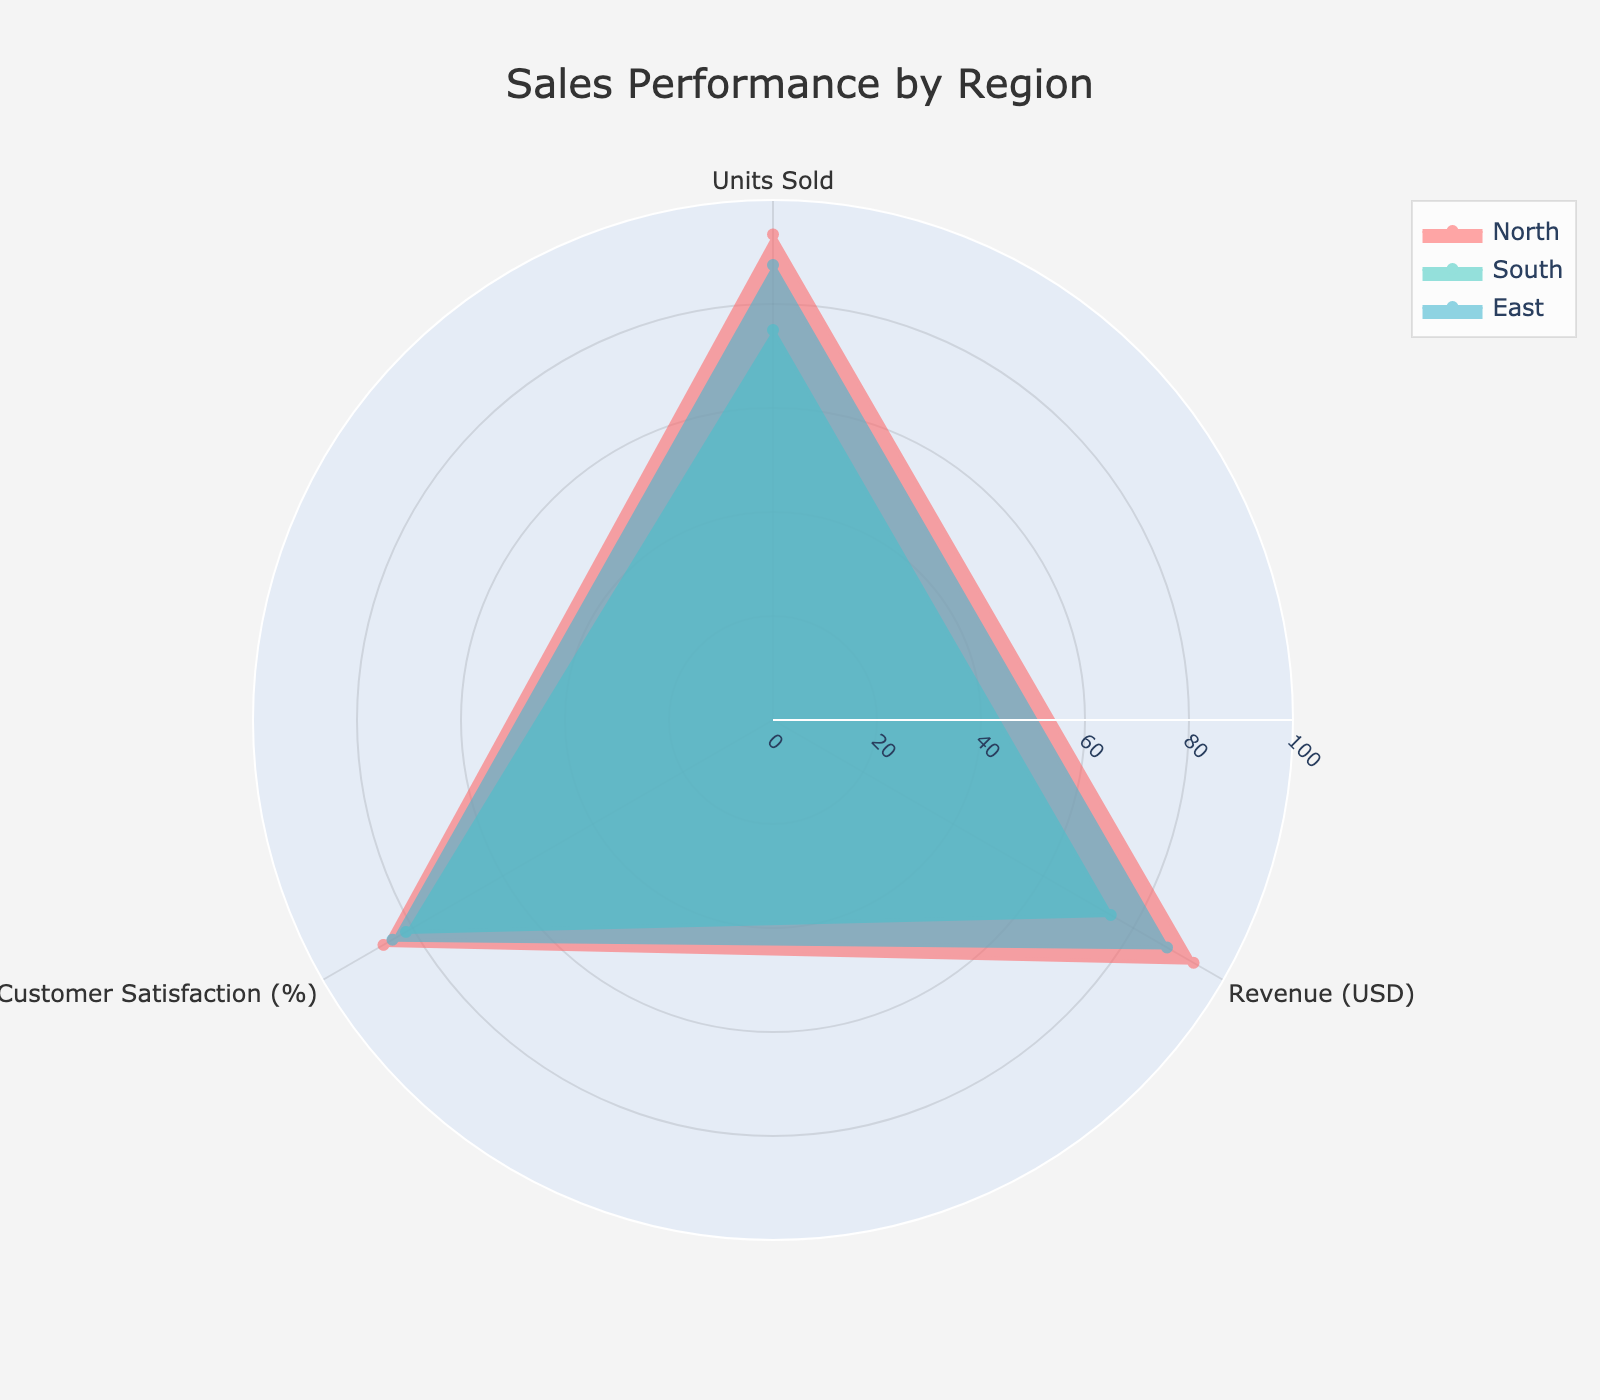What is the title of the chart? The title can be found at the top of the chart. It gives a brief description of what the chart is about.
Answer: Sales Performance by Region How many different regions are compared in the radar chart? Notice the legend or different colored areas in the radar chart. Each color represents a different region.
Answer: 3 Which region has the highest customer satisfaction percentage? Look for the data point on the radar chart that is furthest along the "Customer Satisfaction (%)" axis and identify the corresponding region.
Answer: North What is the average normalized units sold for the South region? Locate the data points for the South region (one of the colored areas) and find the value on the "Units Sold" axis.
Answer: 82.6 Compare the average normalized revenue between the East and North regions. Which one is higher? Track the data points on the "Revenue (USD)" axis for both East and North regions and compare their average values.
Answer: North What are the three categories displayed on the radar chart? Categories are typically shown as labels on the axes of the radar chart.
Answer: Units Sold, Revenue (USD), Customer Satisfaction (%) What is the normalized value for customer satisfaction in the East region? Identify the data point of the East region (one of the colored areas) that corresponds to "Customer Satisfaction (%)" and note its value.
Answer: 84.5 Which region has the lowest average normalized revenue? Examine the average revenue values for all three regions represented on the radar chart and note the lowest one.
Answer: South How does the South region's average normalized units sold compare to the East region's average? Compare the South region's average units sold value with the East region's average units sold value. Note which one is higher.
Answer: East Identify the range of the radial axis in the radar chart. The range of the radial axis is displayed on the chart, often labeled or with tick values.
Answer: 0 to 100 